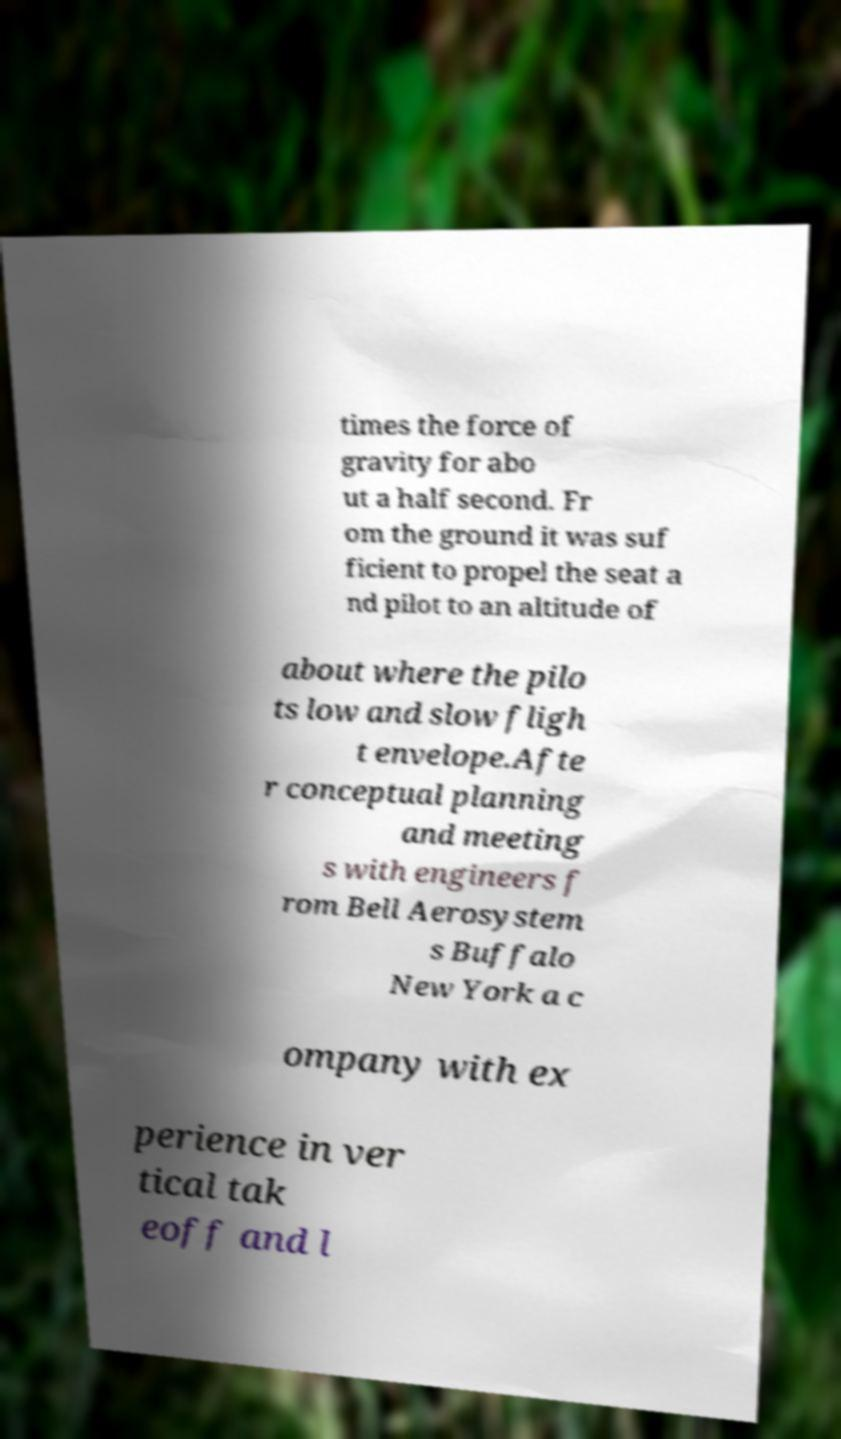Please identify and transcribe the text found in this image. times the force of gravity for abo ut a half second. Fr om the ground it was suf ficient to propel the seat a nd pilot to an altitude of about where the pilo ts low and slow fligh t envelope.Afte r conceptual planning and meeting s with engineers f rom Bell Aerosystem s Buffalo New York a c ompany with ex perience in ver tical tak eoff and l 